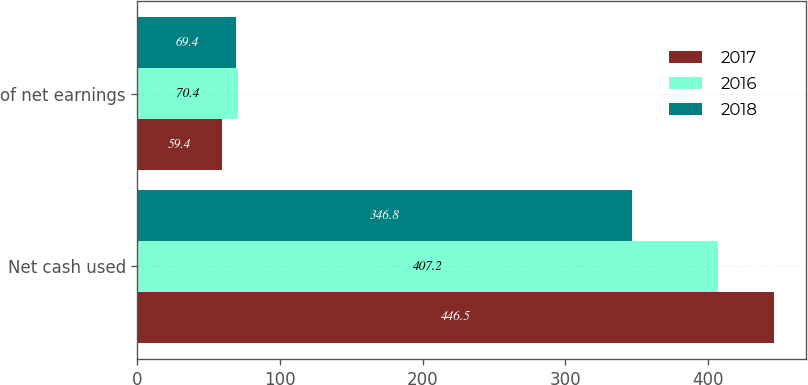Convert chart. <chart><loc_0><loc_0><loc_500><loc_500><stacked_bar_chart><ecel><fcel>Net cash used<fcel>of net earnings<nl><fcel>2017<fcel>446.5<fcel>59.4<nl><fcel>2016<fcel>407.2<fcel>70.4<nl><fcel>2018<fcel>346.8<fcel>69.4<nl></chart> 